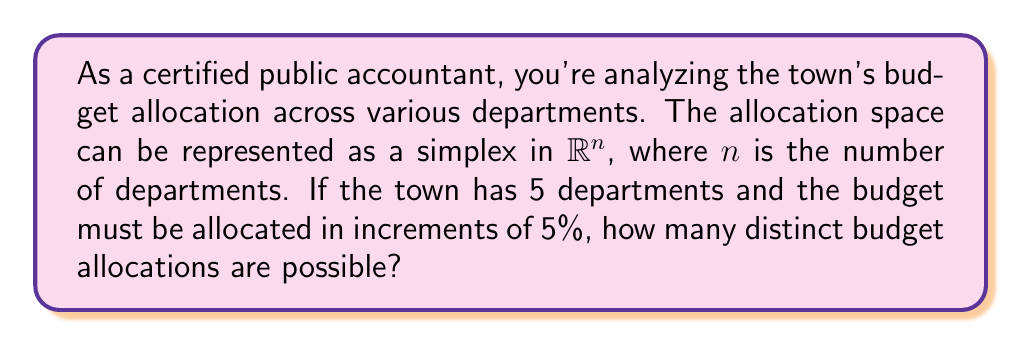Can you answer this question? To solve this problem, we need to understand the concept of a simplex and how it relates to budget allocations:

1) In this case, the budget allocation space is a 4-dimensional simplex in $\mathbb{R}^5$. Each point in this simplex represents a possible budget allocation.

2) The constraint that the allocations must be in increments of 5% means we're looking at a discrete subset of this simplex.

3) This problem is equivalent to finding the number of ways to distribute 20 identical objects (each representing 5% of the budget) into 5 distinct containers (departments).

4) In combinatorics, this is known as a "stars and bars" problem. The formula for this is:

   $${n+k-1 \choose k}$$

   where $n$ is the number of identical objects and $k$ is the number of distinct containers.

5) In our case, $n = 20$ (as we have 20 5% increments) and $k = 5$ (departments).

6) Plugging these values into the formula:

   $${20+5-1 \choose 5} = {24 \choose 5}$$

7) We can calculate this:

   $${24 \choose 5} = \frac{24!}{5!(24-5)!} = \frac{24!}{5!19!} = 42504$$

Therefore, there are 42,504 distinct possible budget allocations.
Answer: 42,504 distinct budget allocations 